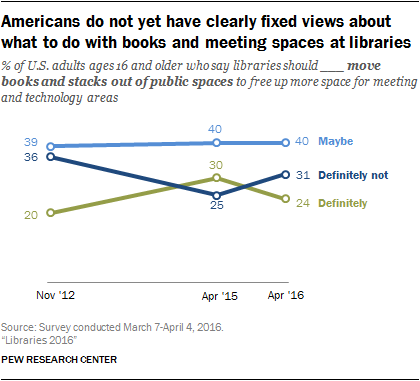Draw attention to some important aspects in this diagram. The average of the medians of the green and light blue graph is 32. The value of blue graph in April 2015 was approximately 40. 